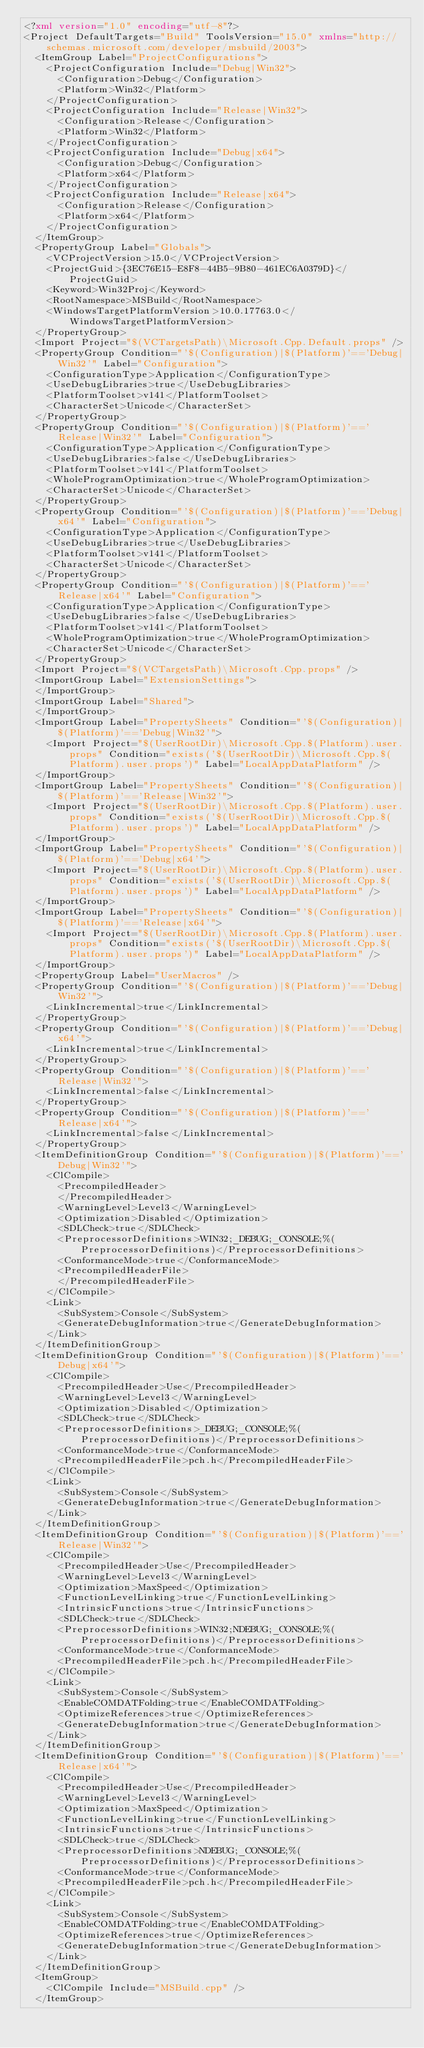<code> <loc_0><loc_0><loc_500><loc_500><_XML_><?xml version="1.0" encoding="utf-8"?>
<Project DefaultTargets="Build" ToolsVersion="15.0" xmlns="http://schemas.microsoft.com/developer/msbuild/2003">
  <ItemGroup Label="ProjectConfigurations">
    <ProjectConfiguration Include="Debug|Win32">
      <Configuration>Debug</Configuration>
      <Platform>Win32</Platform>
    </ProjectConfiguration>
    <ProjectConfiguration Include="Release|Win32">
      <Configuration>Release</Configuration>
      <Platform>Win32</Platform>
    </ProjectConfiguration>
    <ProjectConfiguration Include="Debug|x64">
      <Configuration>Debug</Configuration>
      <Platform>x64</Platform>
    </ProjectConfiguration>
    <ProjectConfiguration Include="Release|x64">
      <Configuration>Release</Configuration>
      <Platform>x64</Platform>
    </ProjectConfiguration>
  </ItemGroup>
  <PropertyGroup Label="Globals">
    <VCProjectVersion>15.0</VCProjectVersion>
    <ProjectGuid>{3EC76E15-E8F8-44B5-9B80-461EC6A0379D}</ProjectGuid>
    <Keyword>Win32Proj</Keyword>
    <RootNamespace>MSBuild</RootNamespace>
    <WindowsTargetPlatformVersion>10.0.17763.0</WindowsTargetPlatformVersion>
  </PropertyGroup>
  <Import Project="$(VCTargetsPath)\Microsoft.Cpp.Default.props" />
  <PropertyGroup Condition="'$(Configuration)|$(Platform)'=='Debug|Win32'" Label="Configuration">
    <ConfigurationType>Application</ConfigurationType>
    <UseDebugLibraries>true</UseDebugLibraries>
    <PlatformToolset>v141</PlatformToolset>
    <CharacterSet>Unicode</CharacterSet>
  </PropertyGroup>
  <PropertyGroup Condition="'$(Configuration)|$(Platform)'=='Release|Win32'" Label="Configuration">
    <ConfigurationType>Application</ConfigurationType>
    <UseDebugLibraries>false</UseDebugLibraries>
    <PlatformToolset>v141</PlatformToolset>
    <WholeProgramOptimization>true</WholeProgramOptimization>
    <CharacterSet>Unicode</CharacterSet>
  </PropertyGroup>
  <PropertyGroup Condition="'$(Configuration)|$(Platform)'=='Debug|x64'" Label="Configuration">
    <ConfigurationType>Application</ConfigurationType>
    <UseDebugLibraries>true</UseDebugLibraries>
    <PlatformToolset>v141</PlatformToolset>
    <CharacterSet>Unicode</CharacterSet>
  </PropertyGroup>
  <PropertyGroup Condition="'$(Configuration)|$(Platform)'=='Release|x64'" Label="Configuration">
    <ConfigurationType>Application</ConfigurationType>
    <UseDebugLibraries>false</UseDebugLibraries>
    <PlatformToolset>v141</PlatformToolset>
    <WholeProgramOptimization>true</WholeProgramOptimization>
    <CharacterSet>Unicode</CharacterSet>
  </PropertyGroup>
  <Import Project="$(VCTargetsPath)\Microsoft.Cpp.props" />
  <ImportGroup Label="ExtensionSettings">
  </ImportGroup>
  <ImportGroup Label="Shared">
  </ImportGroup>
  <ImportGroup Label="PropertySheets" Condition="'$(Configuration)|$(Platform)'=='Debug|Win32'">
    <Import Project="$(UserRootDir)\Microsoft.Cpp.$(Platform).user.props" Condition="exists('$(UserRootDir)\Microsoft.Cpp.$(Platform).user.props')" Label="LocalAppDataPlatform" />
  </ImportGroup>
  <ImportGroup Label="PropertySheets" Condition="'$(Configuration)|$(Platform)'=='Release|Win32'">
    <Import Project="$(UserRootDir)\Microsoft.Cpp.$(Platform).user.props" Condition="exists('$(UserRootDir)\Microsoft.Cpp.$(Platform).user.props')" Label="LocalAppDataPlatform" />
  </ImportGroup>
  <ImportGroup Label="PropertySheets" Condition="'$(Configuration)|$(Platform)'=='Debug|x64'">
    <Import Project="$(UserRootDir)\Microsoft.Cpp.$(Platform).user.props" Condition="exists('$(UserRootDir)\Microsoft.Cpp.$(Platform).user.props')" Label="LocalAppDataPlatform" />
  </ImportGroup>
  <ImportGroup Label="PropertySheets" Condition="'$(Configuration)|$(Platform)'=='Release|x64'">
    <Import Project="$(UserRootDir)\Microsoft.Cpp.$(Platform).user.props" Condition="exists('$(UserRootDir)\Microsoft.Cpp.$(Platform).user.props')" Label="LocalAppDataPlatform" />
  </ImportGroup>
  <PropertyGroup Label="UserMacros" />
  <PropertyGroup Condition="'$(Configuration)|$(Platform)'=='Debug|Win32'">
    <LinkIncremental>true</LinkIncremental>
  </PropertyGroup>
  <PropertyGroup Condition="'$(Configuration)|$(Platform)'=='Debug|x64'">
    <LinkIncremental>true</LinkIncremental>
  </PropertyGroup>
  <PropertyGroup Condition="'$(Configuration)|$(Platform)'=='Release|Win32'">
    <LinkIncremental>false</LinkIncremental>
  </PropertyGroup>
  <PropertyGroup Condition="'$(Configuration)|$(Platform)'=='Release|x64'">
    <LinkIncremental>false</LinkIncremental>
  </PropertyGroup>
  <ItemDefinitionGroup Condition="'$(Configuration)|$(Platform)'=='Debug|Win32'">
    <ClCompile>
      <PrecompiledHeader>
      </PrecompiledHeader>
      <WarningLevel>Level3</WarningLevel>
      <Optimization>Disabled</Optimization>
      <SDLCheck>true</SDLCheck>
      <PreprocessorDefinitions>WIN32;_DEBUG;_CONSOLE;%(PreprocessorDefinitions)</PreprocessorDefinitions>
      <ConformanceMode>true</ConformanceMode>
      <PrecompiledHeaderFile>
      </PrecompiledHeaderFile>
    </ClCompile>
    <Link>
      <SubSystem>Console</SubSystem>
      <GenerateDebugInformation>true</GenerateDebugInformation>
    </Link>
  </ItemDefinitionGroup>
  <ItemDefinitionGroup Condition="'$(Configuration)|$(Platform)'=='Debug|x64'">
    <ClCompile>
      <PrecompiledHeader>Use</PrecompiledHeader>
      <WarningLevel>Level3</WarningLevel>
      <Optimization>Disabled</Optimization>
      <SDLCheck>true</SDLCheck>
      <PreprocessorDefinitions>_DEBUG;_CONSOLE;%(PreprocessorDefinitions)</PreprocessorDefinitions>
      <ConformanceMode>true</ConformanceMode>
      <PrecompiledHeaderFile>pch.h</PrecompiledHeaderFile>
    </ClCompile>
    <Link>
      <SubSystem>Console</SubSystem>
      <GenerateDebugInformation>true</GenerateDebugInformation>
    </Link>
  </ItemDefinitionGroup>
  <ItemDefinitionGroup Condition="'$(Configuration)|$(Platform)'=='Release|Win32'">
    <ClCompile>
      <PrecompiledHeader>Use</PrecompiledHeader>
      <WarningLevel>Level3</WarningLevel>
      <Optimization>MaxSpeed</Optimization>
      <FunctionLevelLinking>true</FunctionLevelLinking>
      <IntrinsicFunctions>true</IntrinsicFunctions>
      <SDLCheck>true</SDLCheck>
      <PreprocessorDefinitions>WIN32;NDEBUG;_CONSOLE;%(PreprocessorDefinitions)</PreprocessorDefinitions>
      <ConformanceMode>true</ConformanceMode>
      <PrecompiledHeaderFile>pch.h</PrecompiledHeaderFile>
    </ClCompile>
    <Link>
      <SubSystem>Console</SubSystem>
      <EnableCOMDATFolding>true</EnableCOMDATFolding>
      <OptimizeReferences>true</OptimizeReferences>
      <GenerateDebugInformation>true</GenerateDebugInformation>
    </Link>
  </ItemDefinitionGroup>
  <ItemDefinitionGroup Condition="'$(Configuration)|$(Platform)'=='Release|x64'">
    <ClCompile>
      <PrecompiledHeader>Use</PrecompiledHeader>
      <WarningLevel>Level3</WarningLevel>
      <Optimization>MaxSpeed</Optimization>
      <FunctionLevelLinking>true</FunctionLevelLinking>
      <IntrinsicFunctions>true</IntrinsicFunctions>
      <SDLCheck>true</SDLCheck>
      <PreprocessorDefinitions>NDEBUG;_CONSOLE;%(PreprocessorDefinitions)</PreprocessorDefinitions>
      <ConformanceMode>true</ConformanceMode>
      <PrecompiledHeaderFile>pch.h</PrecompiledHeaderFile>
    </ClCompile>
    <Link>
      <SubSystem>Console</SubSystem>
      <EnableCOMDATFolding>true</EnableCOMDATFolding>
      <OptimizeReferences>true</OptimizeReferences>
      <GenerateDebugInformation>true</GenerateDebugInformation>
    </Link>
  </ItemDefinitionGroup>
  <ItemGroup>
    <ClCompile Include="MSBuild.cpp" />
  </ItemGroup></code> 